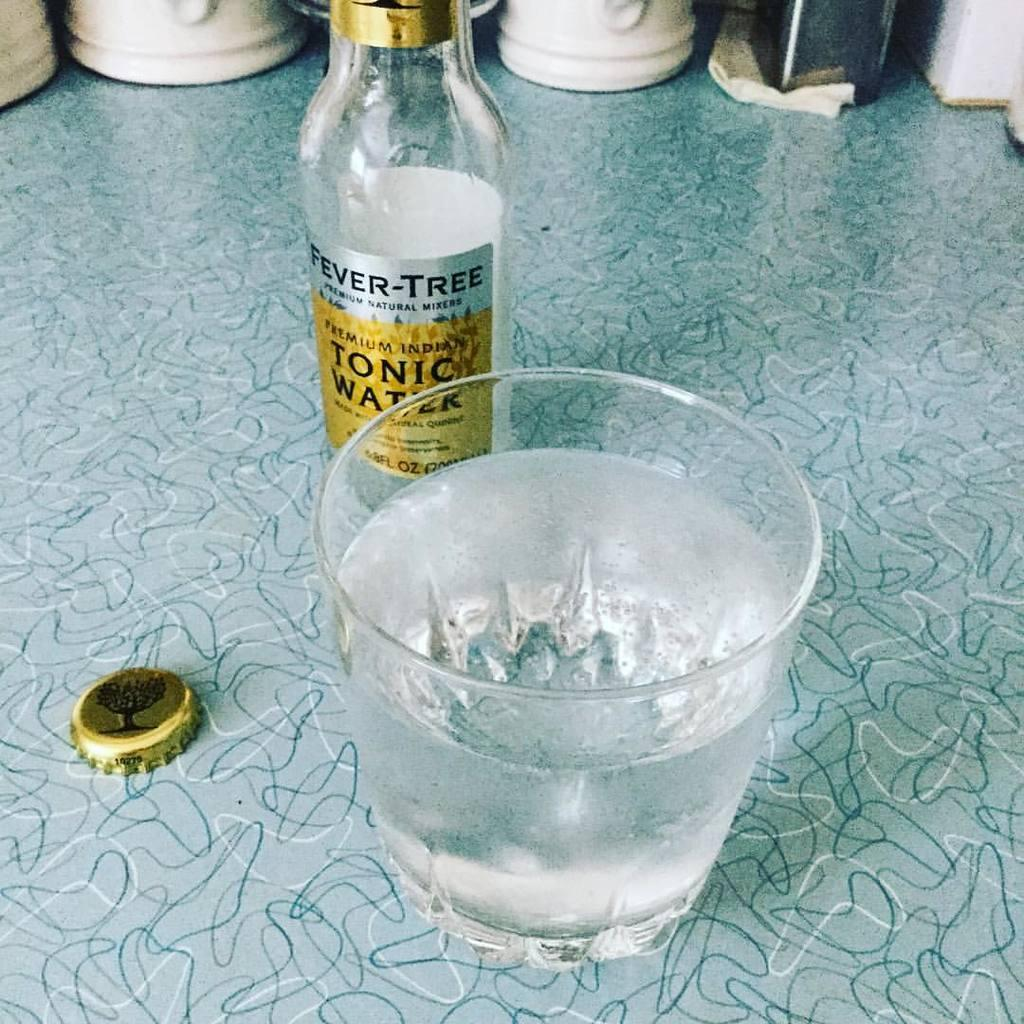<image>
Provide a brief description of the given image. A River Tree beverage poured into a glass. 